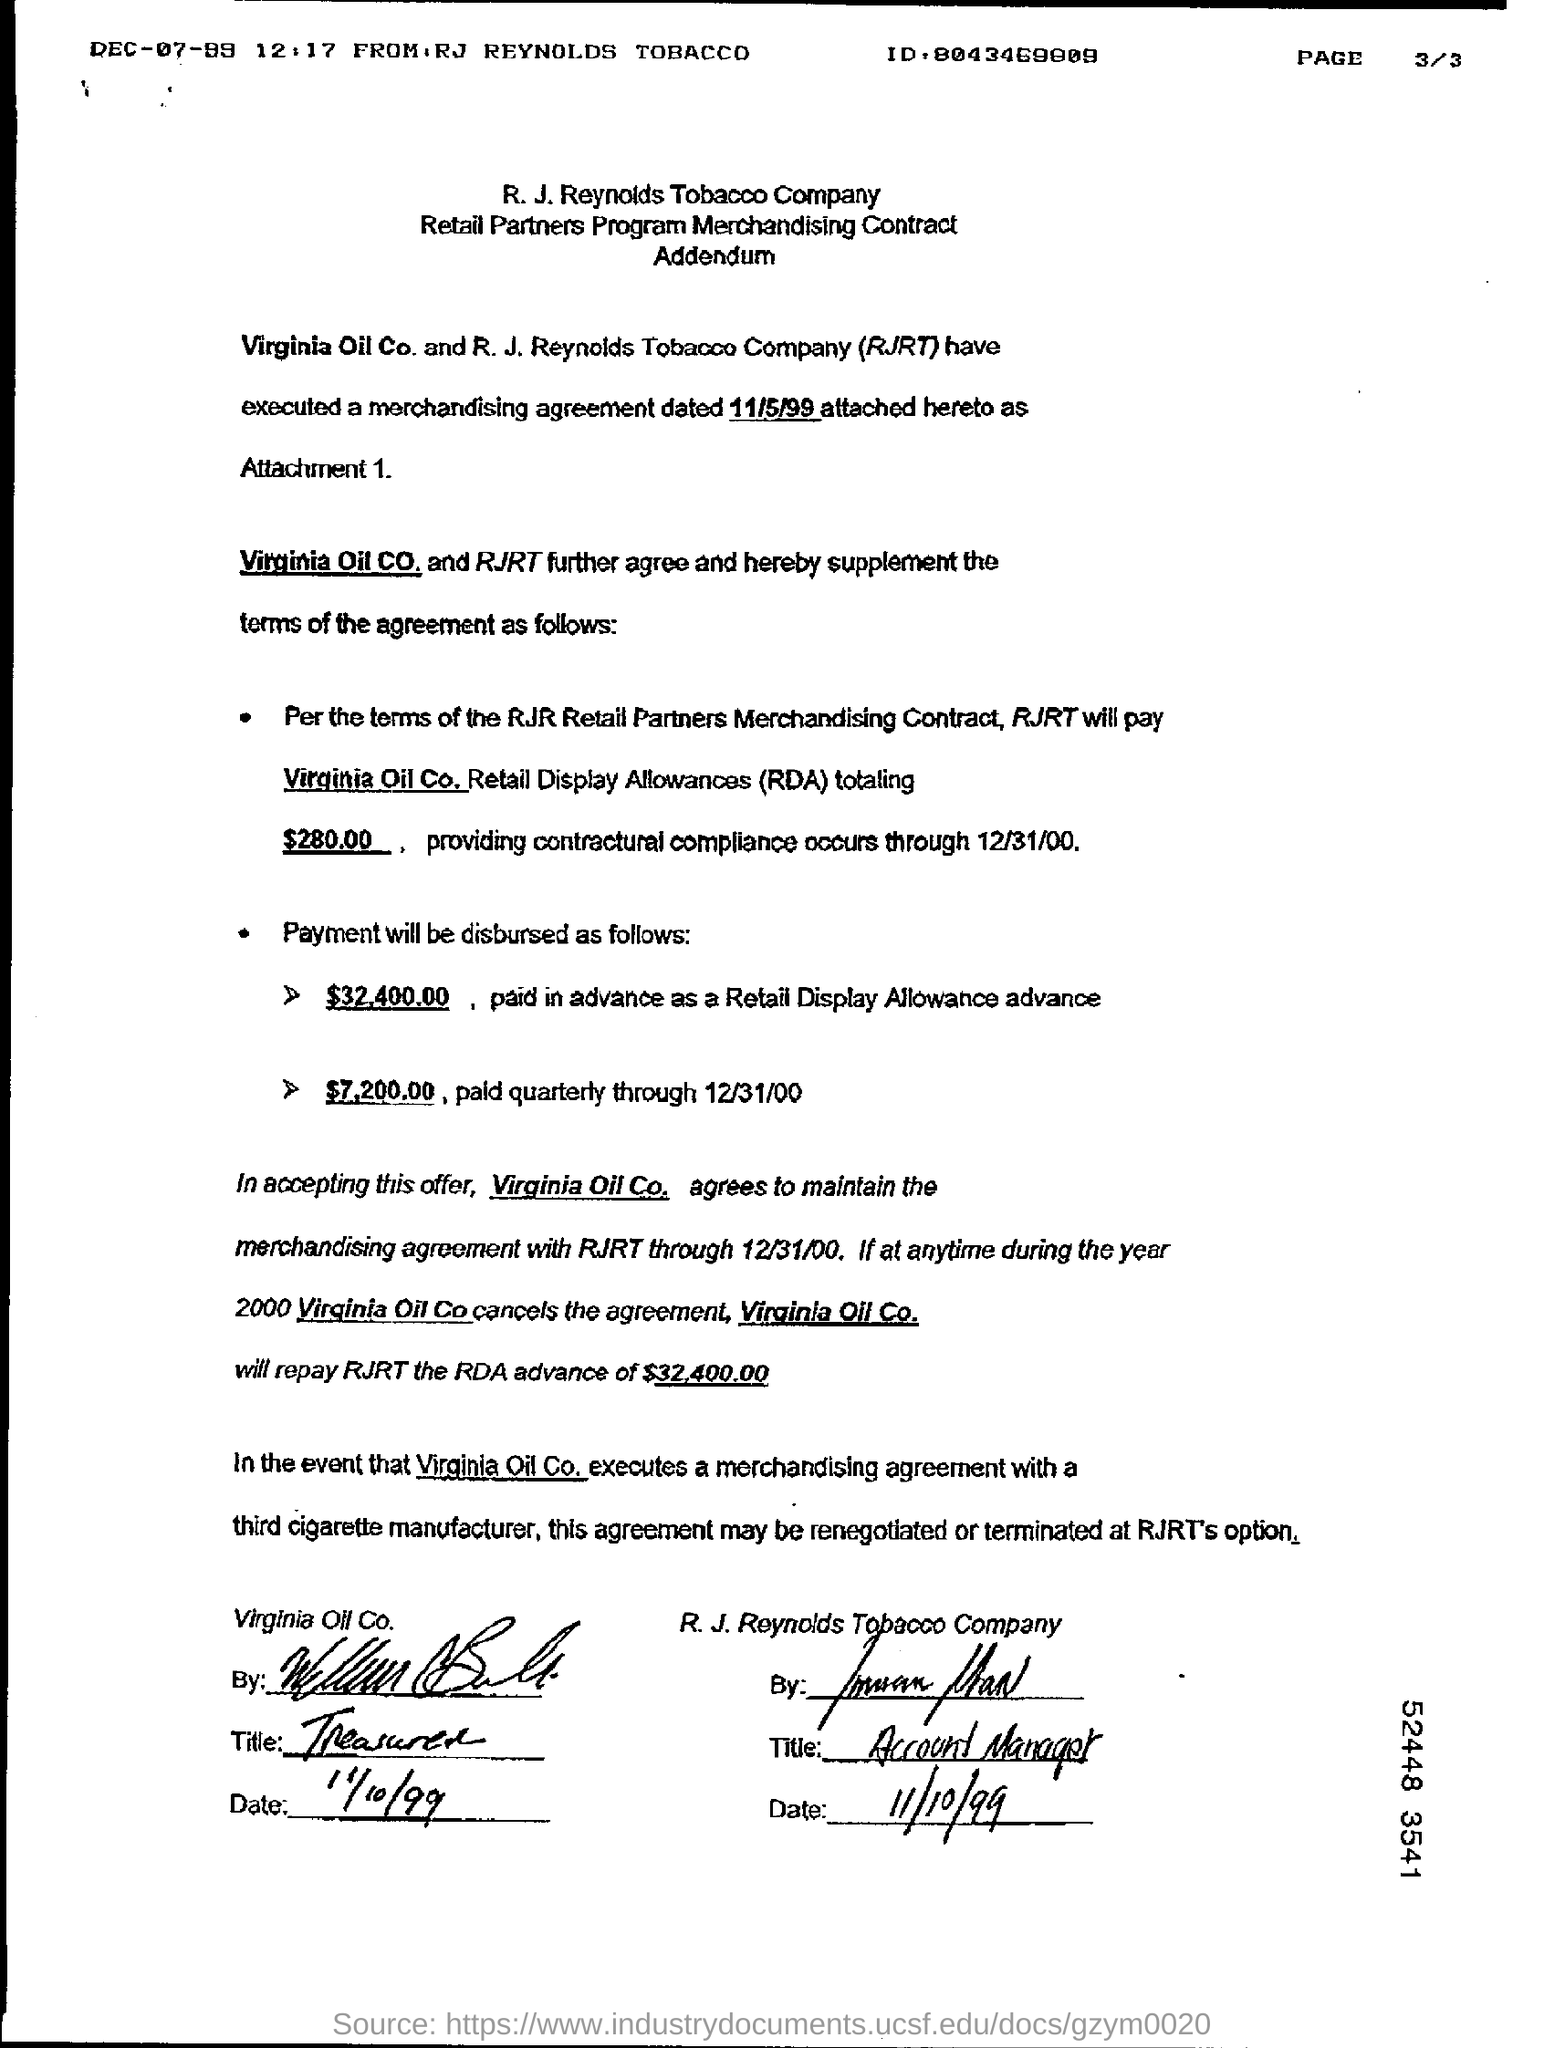When is the agreement dated?
Offer a very short reply. 11/5/99. 